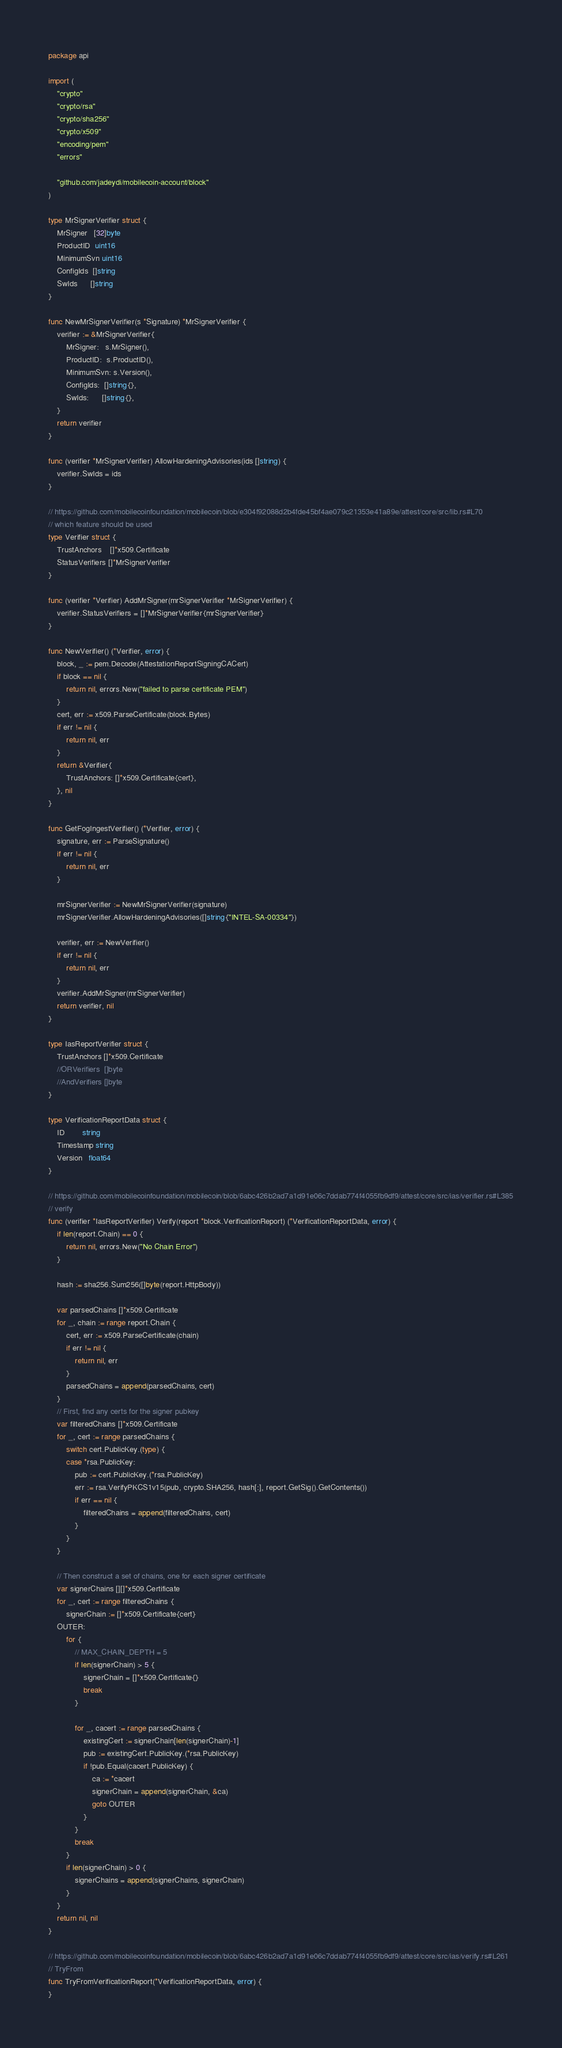Convert code to text. <code><loc_0><loc_0><loc_500><loc_500><_Go_>package api

import (
	"crypto"
	"crypto/rsa"
	"crypto/sha256"
	"crypto/x509"
	"encoding/pem"
	"errors"

	"github.com/jadeydi/mobilecoin-account/block"
)

type MrSignerVerifier struct {
	MrSigner   [32]byte
	ProductID  uint16
	MinimumSvn uint16
	ConfigIds  []string
	SwIds      []string
}

func NewMrSignerVerifier(s *Signature) *MrSignerVerifier {
	verifier := &MrSignerVerifier{
		MrSigner:   s.MrSigner(),
		ProductID:  s.ProductID(),
		MinimumSvn: s.Version(),
		ConfigIds:  []string{},
		SwIds:      []string{},
	}
	return verifier
}

func (verifier *MrSignerVerifier) AllowHardeningAdvisories(ids []string) {
	verifier.SwIds = ids
}

// https://github.com/mobilecoinfoundation/mobilecoin/blob/e304f92088d2b4fde45bf4ae079c21353e41a89e/attest/core/src/lib.rs#L70
// which feature should be used
type Verifier struct {
	TrustAnchors    []*x509.Certificate
	StatusVerifiers []*MrSignerVerifier
}

func (verifier *Verifier) AddMrSigner(mrSignerVerifier *MrSignerVerifier) {
	verifier.StatusVerifiers = []*MrSignerVerifier{mrSignerVerifier}
}

func NewVerifier() (*Verifier, error) {
	block, _ := pem.Decode(AttestationReportSigningCACert)
	if block == nil {
		return nil, errors.New("failed to parse certificate PEM")
	}
	cert, err := x509.ParseCertificate(block.Bytes)
	if err != nil {
		return nil, err
	}
	return &Verifier{
		TrustAnchors: []*x509.Certificate{cert},
	}, nil
}

func GetFogIngestVerifier() (*Verifier, error) {
	signature, err := ParseSignature()
	if err != nil {
		return nil, err
	}

	mrSignerVerifier := NewMrSignerVerifier(signature)
	mrSignerVerifier.AllowHardeningAdvisories([]string{"INTEL-SA-00334"})

	verifier, err := NewVerifier()
	if err != nil {
		return nil, err
	}
	verifier.AddMrSigner(mrSignerVerifier)
	return verifier, nil
}

type IasReportVerifier struct {
	TrustAnchors []*x509.Certificate
	//ORVerifiers  []byte
	//AndVerifiers []byte
}

type VerificationReportData struct {
	ID        string
	Timestamp string
	Version   float64
}

// https://github.com/mobilecoinfoundation/mobilecoin/blob/6abc426b2ad7a1d91e06c7ddab774f4055fb9df9/attest/core/src/ias/verifier.rs#L385
// verify
func (verifier *IasReportVerifier) Verify(report *block.VerificationReport) (*VerificationReportData, error) {
	if len(report.Chain) == 0 {
		return nil, errors.New("No Chain Error")
	}

	hash := sha256.Sum256([]byte(report.HttpBody))

	var parsedChains []*x509.Certificate
	for _, chain := range report.Chain {
		cert, err := x509.ParseCertificate(chain)
		if err != nil {
			return nil, err
		}
		parsedChains = append(parsedChains, cert)
	}
	// First, find any certs for the signer pubkey
	var filteredChains []*x509.Certificate
	for _, cert := range parsedChains {
		switch cert.PublicKey.(type) {
		case *rsa.PublicKey:
			pub := cert.PublicKey.(*rsa.PublicKey)
			err := rsa.VerifyPKCS1v15(pub, crypto.SHA256, hash[:], report.GetSig().GetContents())
			if err == nil {
				filteredChains = append(filteredChains, cert)
			}
		}
	}

	// Then construct a set of chains, one for each signer certificate
	var signerChains [][]*x509.Certificate
	for _, cert := range filteredChains {
		signerChain := []*x509.Certificate{cert}
	OUTER:
		for {
			// MAX_CHAIN_DEPTH = 5
			if len(signerChain) > 5 {
				signerChain = []*x509.Certificate{}
				break
			}

			for _, cacert := range parsedChains {
				existingCert := signerChain[len(signerChain)-1]
				pub := existingCert.PublicKey.(*rsa.PublicKey)
				if !pub.Equal(cacert.PublicKey) {
					ca := *cacert
					signerChain = append(signerChain, &ca)
					goto OUTER
				}
			}
			break
		}
		if len(signerChain) > 0 {
			signerChains = append(signerChains, signerChain)
		}
	}
	return nil, nil
}

// https://github.com/mobilecoinfoundation/mobilecoin/blob/6abc426b2ad7a1d91e06c7ddab774f4055fb9df9/attest/core/src/ias/verify.rs#L261
// TryFrom
func TryFromVerificationReport(*VerificationReportData, error) {
}
</code> 